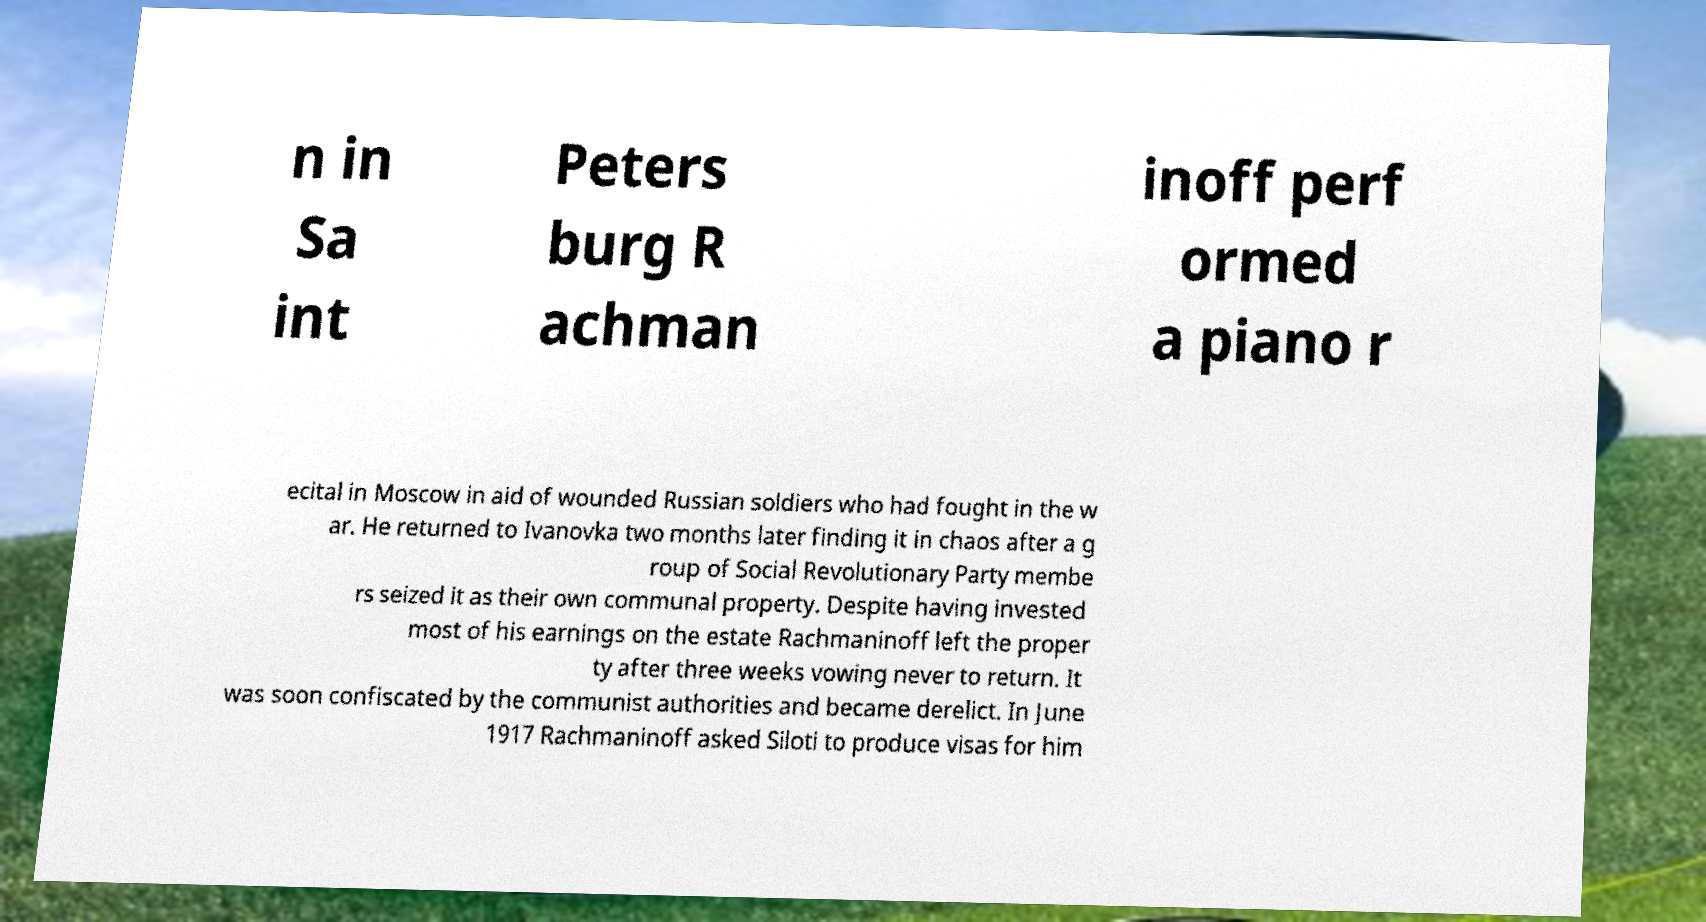What messages or text are displayed in this image? I need them in a readable, typed format. n in Sa int Peters burg R achman inoff perf ormed a piano r ecital in Moscow in aid of wounded Russian soldiers who had fought in the w ar. He returned to Ivanovka two months later finding it in chaos after a g roup of Social Revolutionary Party membe rs seized it as their own communal property. Despite having invested most of his earnings on the estate Rachmaninoff left the proper ty after three weeks vowing never to return. It was soon confiscated by the communist authorities and became derelict. In June 1917 Rachmaninoff asked Siloti to produce visas for him 